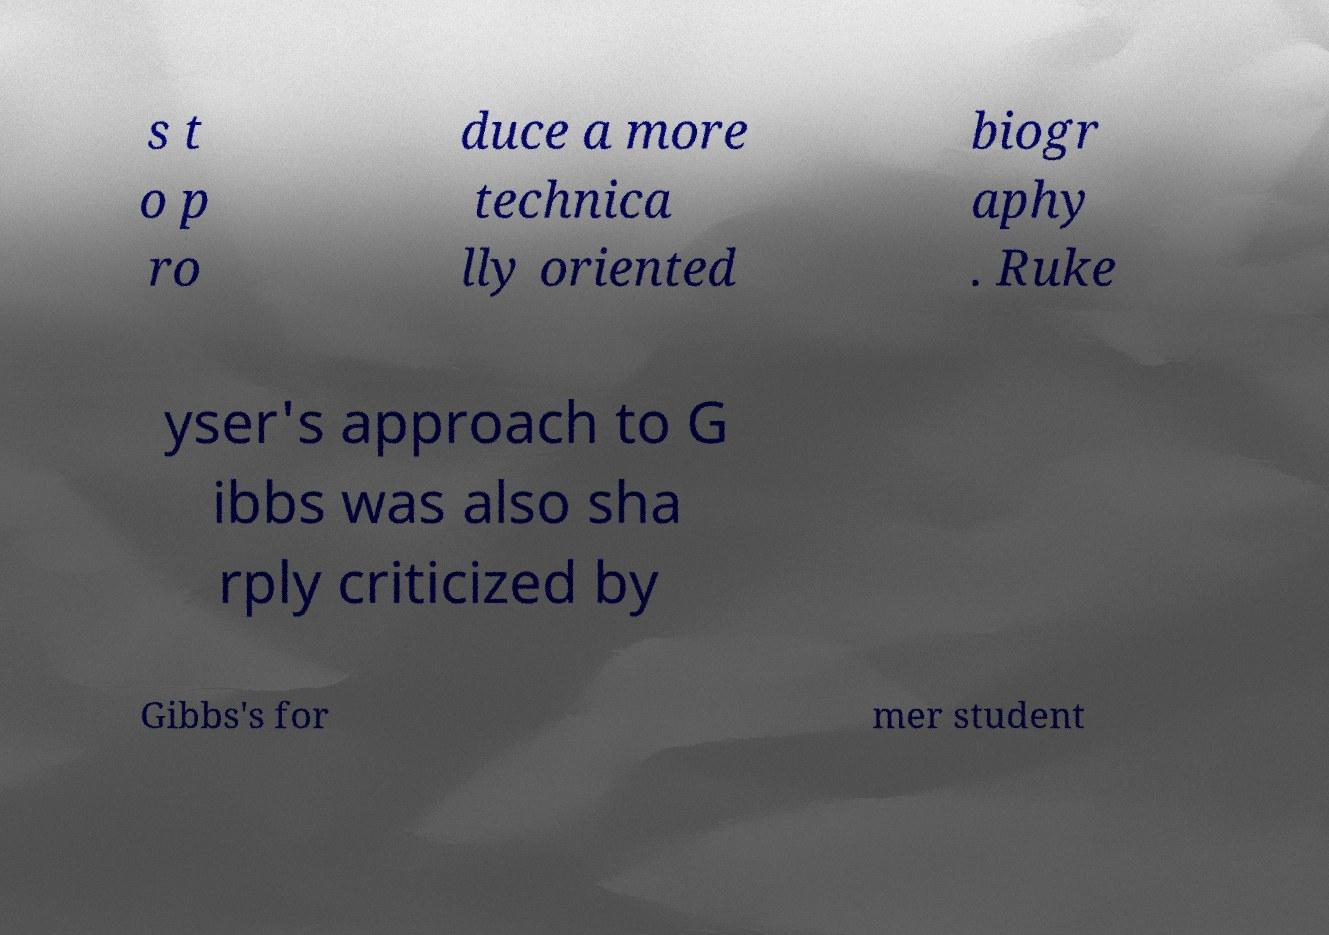For documentation purposes, I need the text within this image transcribed. Could you provide that? s t o p ro duce a more technica lly oriented biogr aphy . Ruke yser's approach to G ibbs was also sha rply criticized by Gibbs's for mer student 